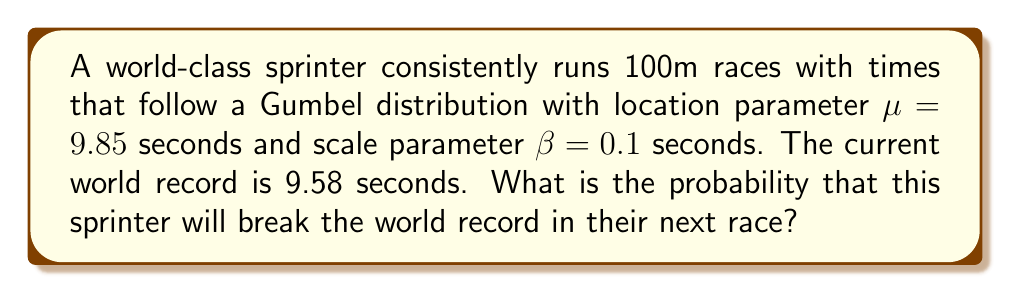Help me with this question. To solve this problem, we'll use the cumulative distribution function (CDF) of the Gumbel distribution. The steps are as follows:

1) The CDF of the Gumbel distribution is given by:

   $$F(x) = e^{-e^{-(x-\mu)/\beta}}$$

   where $\mu$ is the location parameter and $\beta$ is the scale parameter.

2) We want to find the probability that the sprinter's time is less than 9.58 seconds. This is equivalent to:

   $$P(X \leq 9.58) = F(9.58)$$

3) Substituting the values into the CDF:

   $$F(9.58) = e^{-e^{-(9.58-9.85)/0.1}}$$

4) Let's solve the inner exponent first:
   
   $$(9.58 - 9.85) / 0.1 = -2.7$$

5) Now our equation looks like:

   $$F(9.58) = e^{-e^{2.7}}$$

6) Calculate $e^{2.7}$:

   $$e^{2.7} \approx 14.8797$$

7) Our equation is now:

   $$F(9.58) = e^{-14.8797}$$

8) Calculate the final result:

   $$F(9.58) \approx 3.4492 \times 10^{-7}$$

9) Convert to a percentage:

   $$3.4492 \times 10^{-7} \times 100\% \approx 0.000034492\%$$

This extremely small probability reflects the difficulty of breaking a world record in a single attempt.
Answer: $3.4492 \times 10^{-7}$ or approximately $0.000034492\%$ 